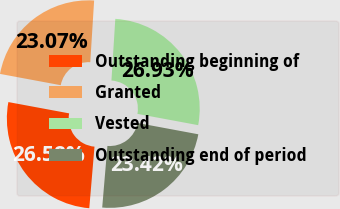<chart> <loc_0><loc_0><loc_500><loc_500><pie_chart><fcel>Outstanding beginning of<fcel>Granted<fcel>Vested<fcel>Outstanding end of period<nl><fcel>26.58%<fcel>23.07%<fcel>26.93%<fcel>23.42%<nl></chart> 